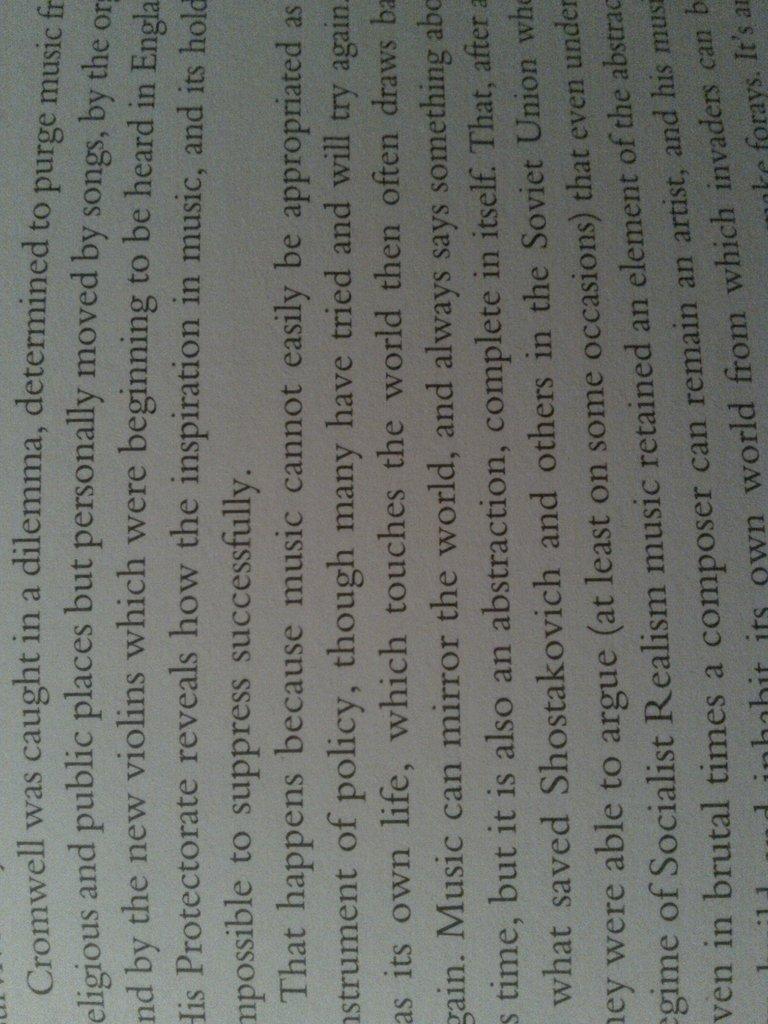Who was caught in a dilemma?
Your response must be concise. Cromwell. What kind of regime is referred to?
Offer a very short reply. Socialist realism. 